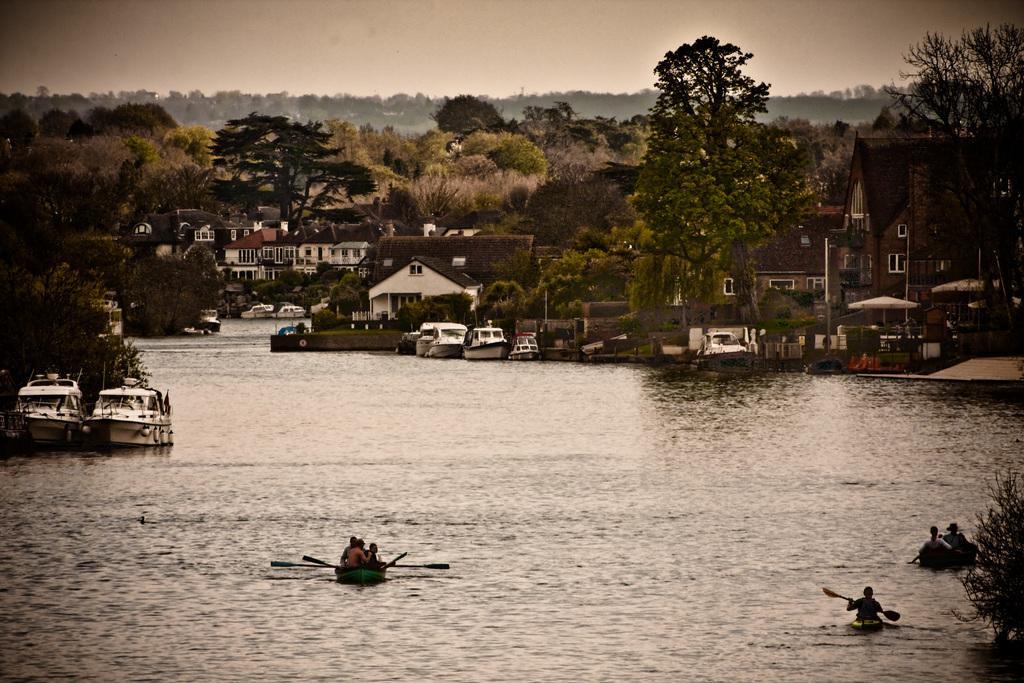Please provide a concise description of this image. In this image I can see fleets of boats and a group of people in the water, plants, trees, houses, buildings and the sky. This image is taken may be near the lake. 